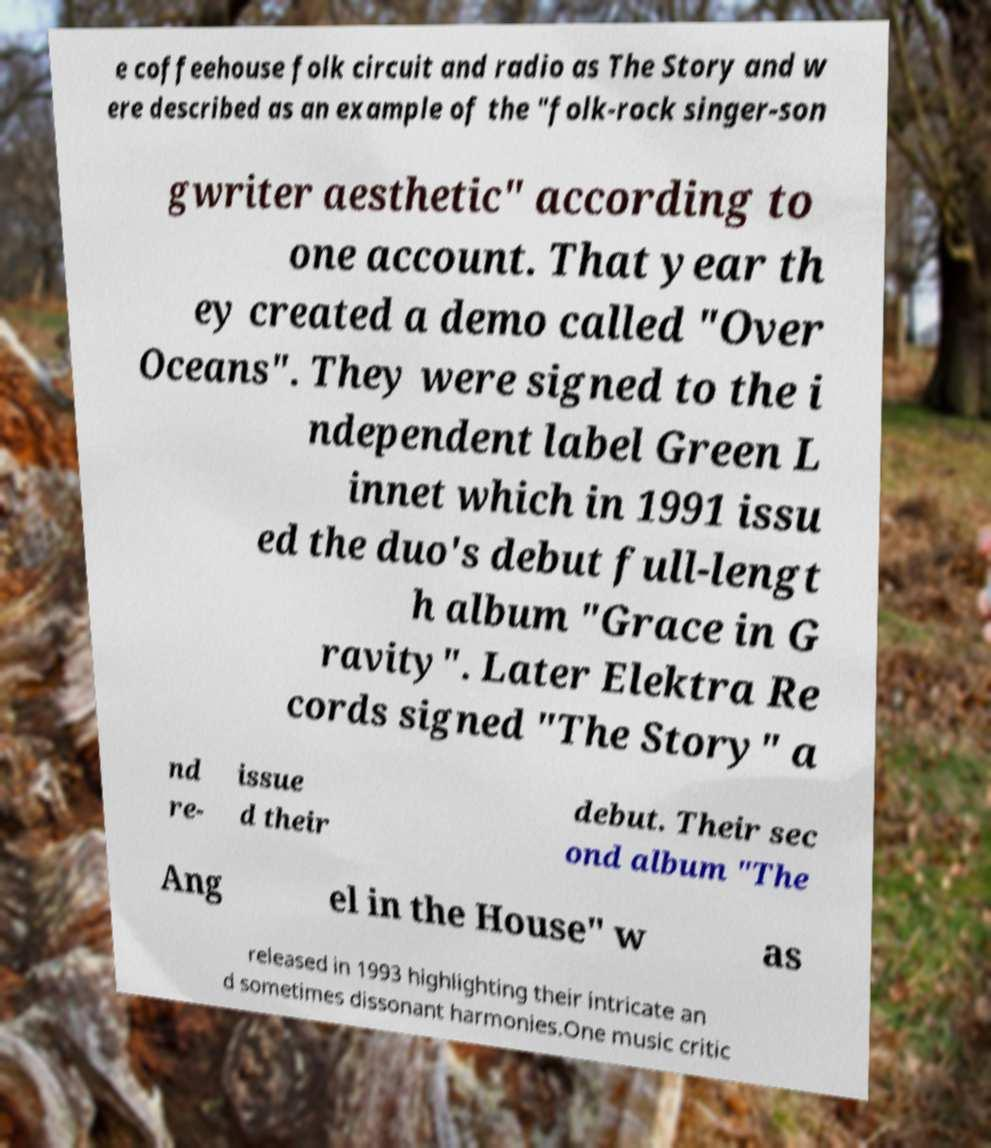There's text embedded in this image that I need extracted. Can you transcribe it verbatim? e coffeehouse folk circuit and radio as The Story and w ere described as an example of the "folk-rock singer-son gwriter aesthetic" according to one account. That year th ey created a demo called "Over Oceans". They were signed to the i ndependent label Green L innet which in 1991 issu ed the duo's debut full-lengt h album "Grace in G ravity". Later Elektra Re cords signed "The Story" a nd re- issue d their debut. Their sec ond album "The Ang el in the House" w as released in 1993 highlighting their intricate an d sometimes dissonant harmonies.One music critic 